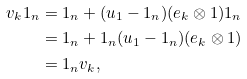Convert formula to latex. <formula><loc_0><loc_0><loc_500><loc_500>v _ { k } 1 _ { n } & = 1 _ { n } + ( u _ { 1 } - 1 _ { n } ) ( e _ { k } \otimes 1 ) 1 _ { n } \\ & = 1 _ { n } + 1 _ { n } ( u _ { 1 } - 1 _ { n } ) ( e _ { k } \otimes 1 ) \\ & = 1 _ { n } v _ { k } ,</formula> 